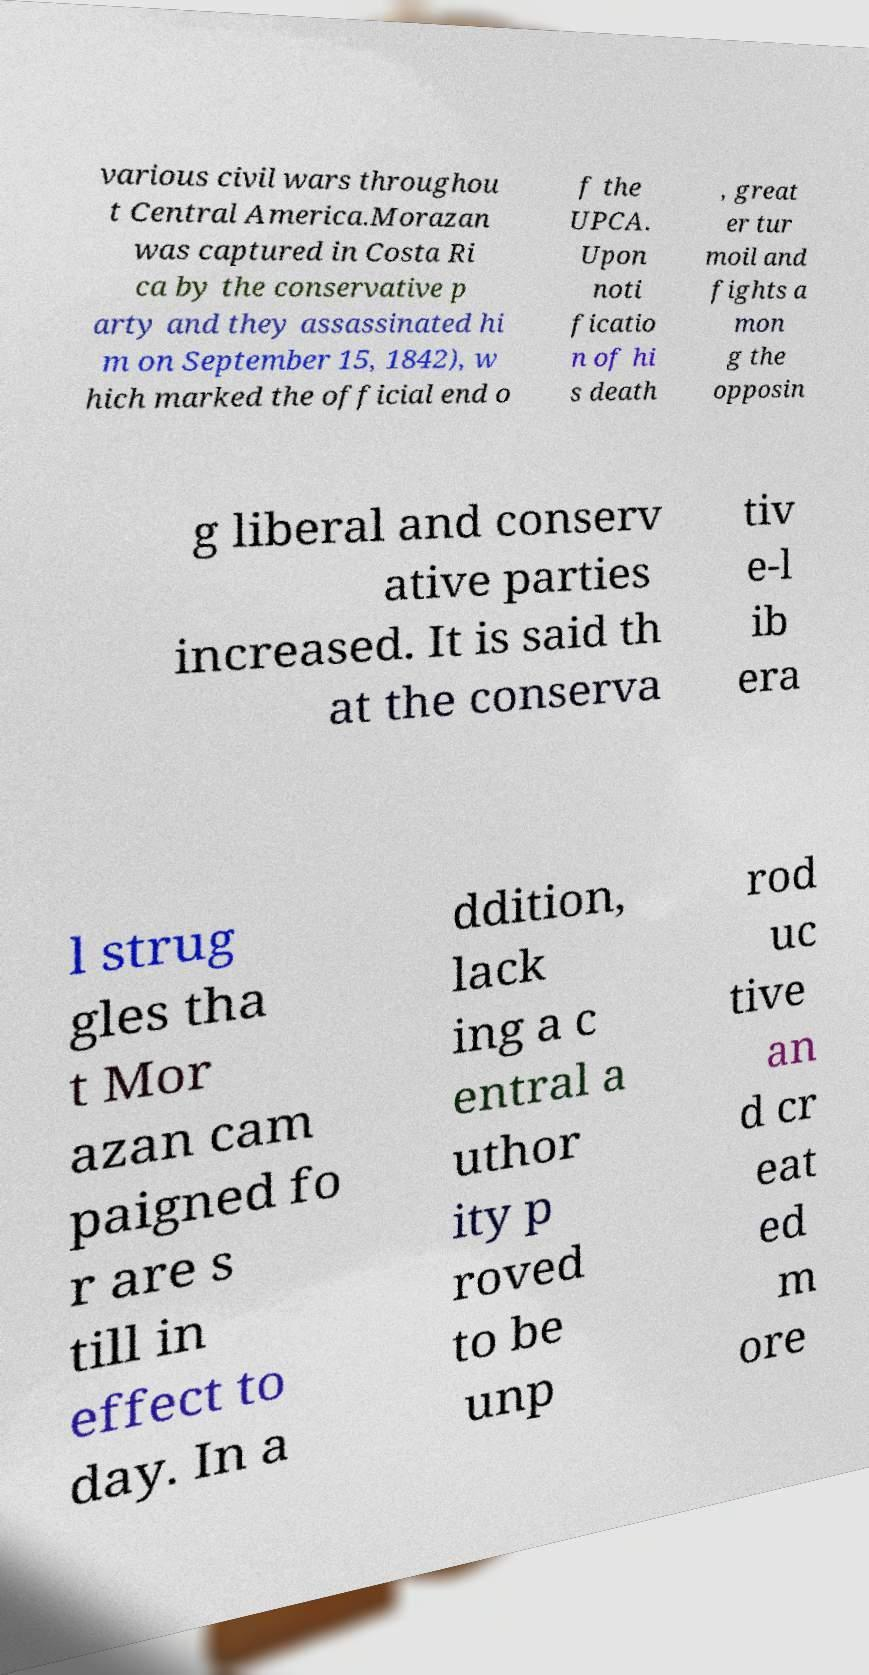Could you assist in decoding the text presented in this image and type it out clearly? various civil wars throughou t Central America.Morazan was captured in Costa Ri ca by the conservative p arty and they assassinated hi m on September 15, 1842), w hich marked the official end o f the UPCA. Upon noti ficatio n of hi s death , great er tur moil and fights a mon g the opposin g liberal and conserv ative parties increased. It is said th at the conserva tiv e-l ib era l strug gles tha t Mor azan cam paigned fo r are s till in effect to day. In a ddition, lack ing a c entral a uthor ity p roved to be unp rod uc tive an d cr eat ed m ore 